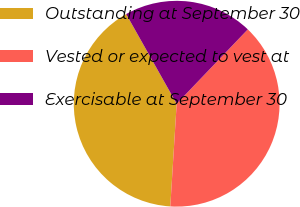Convert chart. <chart><loc_0><loc_0><loc_500><loc_500><pie_chart><fcel>Outstanding at September 30<fcel>Vested or expected to vest at<fcel>Exercisable at September 30<nl><fcel>40.85%<fcel>38.84%<fcel>20.31%<nl></chart> 